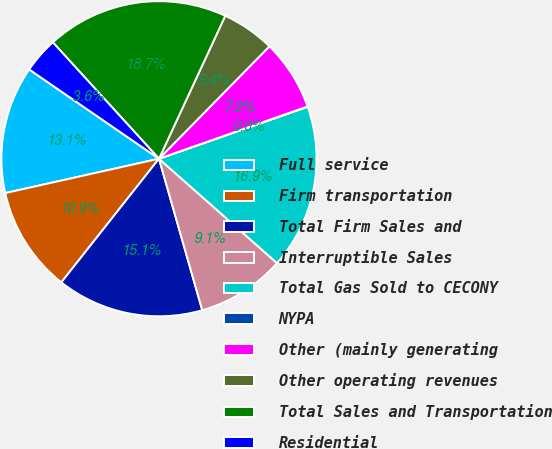Convert chart to OTSL. <chart><loc_0><loc_0><loc_500><loc_500><pie_chart><fcel>Full service<fcel>Firm transportation<fcel>Total Firm Sales and<fcel>Interruptible Sales<fcel>Total Gas Sold to CECONY<fcel>NYPA<fcel>Other (mainly generating<fcel>Other operating revenues<fcel>Total Sales and Transportation<fcel>Residential<nl><fcel>13.09%<fcel>10.86%<fcel>15.07%<fcel>9.05%<fcel>16.87%<fcel>0.04%<fcel>7.25%<fcel>5.45%<fcel>18.68%<fcel>3.64%<nl></chart> 